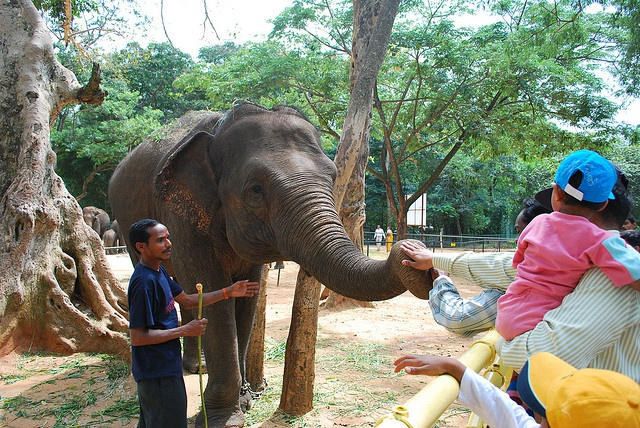Describe the objects in this image and their specific colors. I can see elephant in gray, black, and darkgray tones, people in gray, darkgray, lightgray, lightblue, and olive tones, people in gray, violet, and brown tones, people in gray, black, maroon, and navy tones, and people in gray, orange, gold, white, and darkgray tones in this image. 